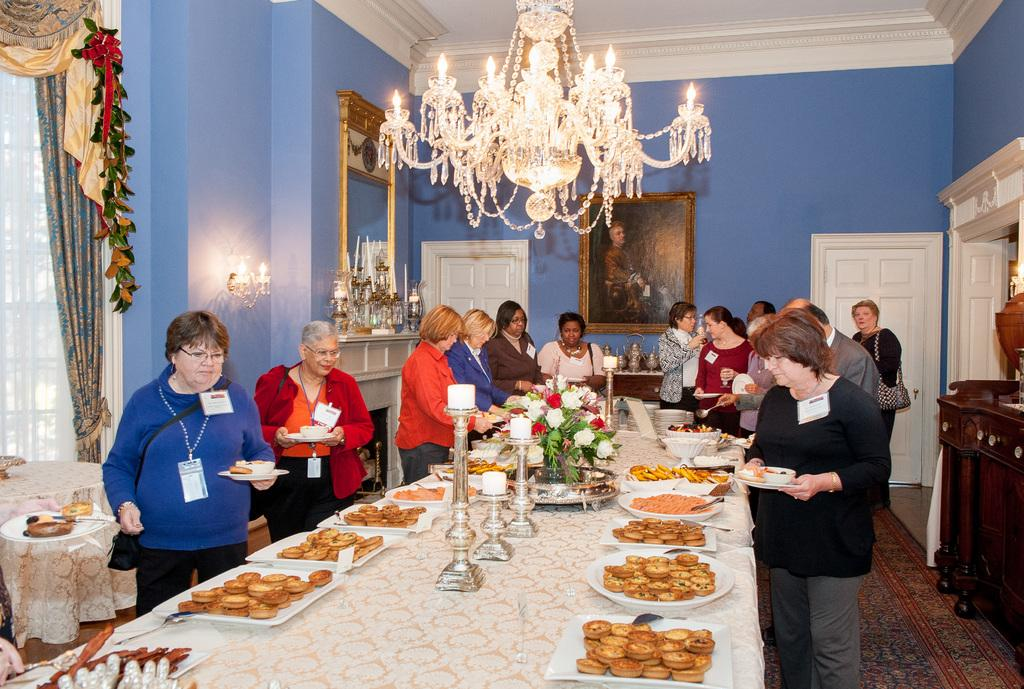What type of structure can be seen in the image? There is a wall in the image. What is hanging on the wall? There is a photo frame in the image. Is there any entrance or exit visible in the image? Yes, there is a door in the image. What type of lighting fixture is present in the image? There is a chandelier in the image. What piece of furniture is in the image? There is a table in the image. What is on top of the table? There are plates and food items on the table. How many snails can be seen crawling on the table in the image? There are no snails present in the image. What type of pollution is visible in the image? There is no pollution visible in the image. 